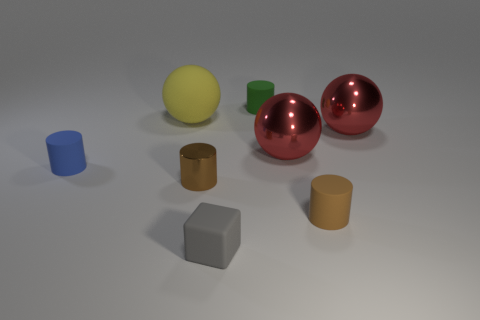Subtract 1 cylinders. How many cylinders are left? 3 Add 1 brown things. How many objects exist? 9 Subtract all cubes. How many objects are left? 7 Add 5 matte cylinders. How many matte cylinders exist? 8 Subtract 0 red cylinders. How many objects are left? 8 Subtract all large purple metallic objects. Subtract all brown cylinders. How many objects are left? 6 Add 6 blue matte objects. How many blue matte objects are left? 7 